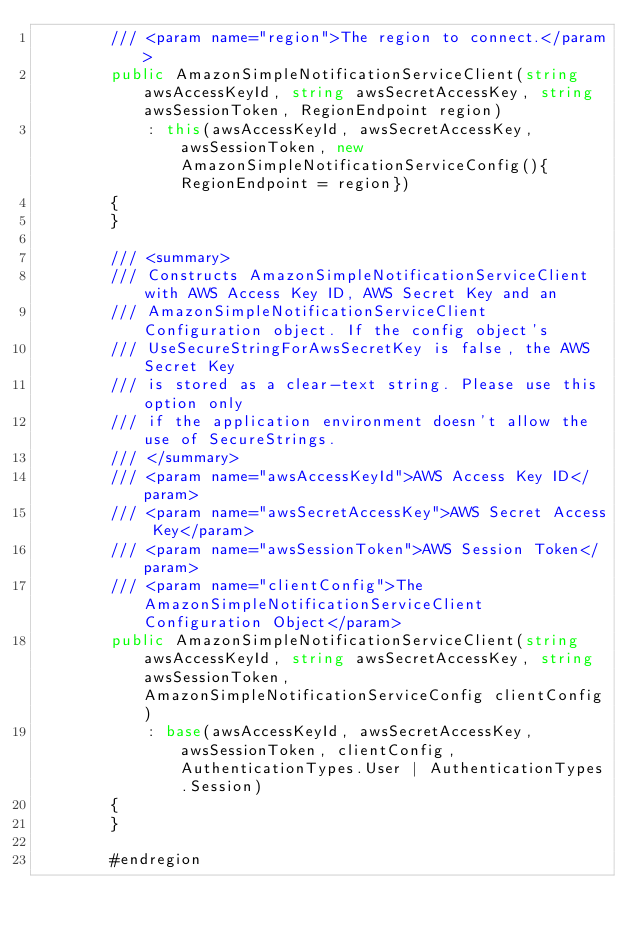Convert code to text. <code><loc_0><loc_0><loc_500><loc_500><_C#_>        /// <param name="region">The region to connect.</param>
        public AmazonSimpleNotificationServiceClient(string awsAccessKeyId, string awsSecretAccessKey, string awsSessionToken, RegionEndpoint region)
            : this(awsAccessKeyId, awsSecretAccessKey, awsSessionToken, new AmazonSimpleNotificationServiceConfig(){RegionEndpoint = region})
        {
        }

        /// <summary>
        /// Constructs AmazonSimpleNotificationServiceClient with AWS Access Key ID, AWS Secret Key and an
        /// AmazonSimpleNotificationServiceClient Configuration object. If the config object's
        /// UseSecureStringForAwsSecretKey is false, the AWS Secret Key
        /// is stored as a clear-text string. Please use this option only
        /// if the application environment doesn't allow the use of SecureStrings.
        /// </summary>
        /// <param name="awsAccessKeyId">AWS Access Key ID</param>
        /// <param name="awsSecretAccessKey">AWS Secret Access Key</param>
        /// <param name="awsSessionToken">AWS Session Token</param>
        /// <param name="clientConfig">The AmazonSimpleNotificationServiceClient Configuration Object</param>
        public AmazonSimpleNotificationServiceClient(string awsAccessKeyId, string awsSecretAccessKey, string awsSessionToken, AmazonSimpleNotificationServiceConfig clientConfig)
            : base(awsAccessKeyId, awsSecretAccessKey, awsSessionToken, clientConfig, AuthenticationTypes.User | AuthenticationTypes.Session)
        {
        }

        #endregion

 </code> 